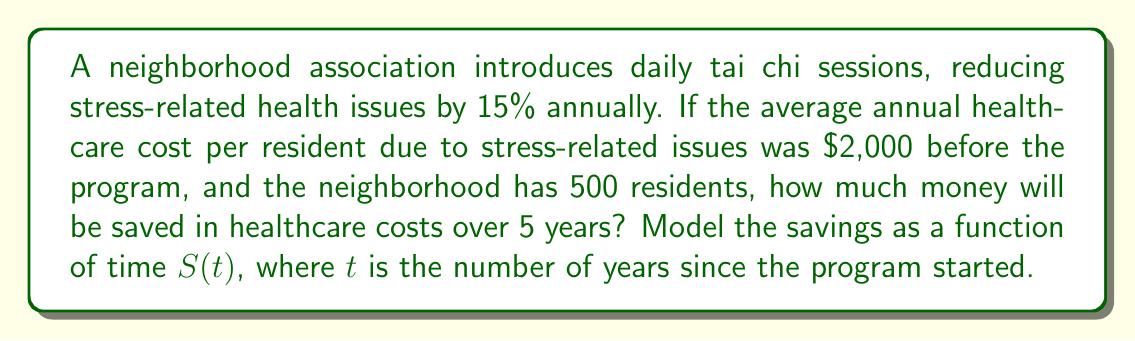Give your solution to this math problem. Let's approach this step-by-step:

1) First, calculate the annual savings per resident:
   $2,000 \times 15\% = $300$

2) Total annual savings for all residents:
   $300 \times 500 = $150,000$

3) To model the savings over time, we need a function $S(t)$ where $t$ is the number of years:
   $S(t) = 150,000t$

4) To find the total savings over 5 years, we evaluate $S(5)$:
   $S(5) = 150,000 \times 5 = $750,000$

Therefore, the function modeling the savings over time is:

$$ S(t) = 150,000t $$

And the total savings over 5 years is $750,000.
Answer: $750,000 